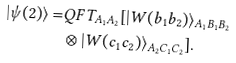Convert formula to latex. <formula><loc_0><loc_0><loc_500><loc_500>| \psi ( 2 ) \rangle = & Q F T _ { A _ { 1 } A _ { 2 } } [ | W ( b _ { 1 } b _ { 2 } ) \rangle _ { A _ { 1 } B _ { 1 } B _ { 2 } } \\ & \otimes | W ( c _ { 1 } c _ { 2 } ) \rangle _ { A _ { 2 } C _ { 1 } C _ { 2 } } ] .</formula> 